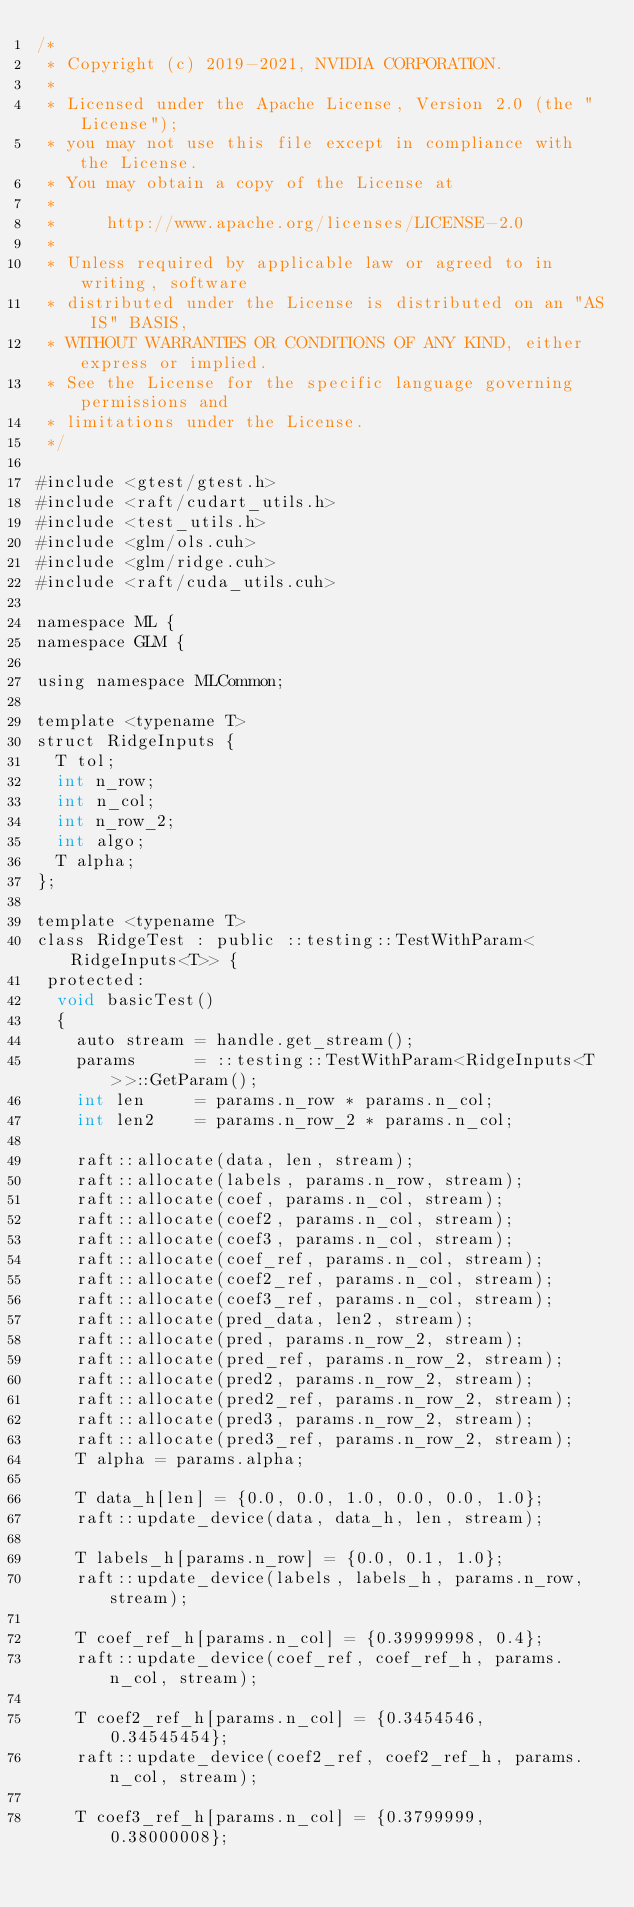Convert code to text. <code><loc_0><loc_0><loc_500><loc_500><_Cuda_>/*
 * Copyright (c) 2019-2021, NVIDIA CORPORATION.
 *
 * Licensed under the Apache License, Version 2.0 (the "License");
 * you may not use this file except in compliance with the License.
 * You may obtain a copy of the License at
 *
 *     http://www.apache.org/licenses/LICENSE-2.0
 *
 * Unless required by applicable law or agreed to in writing, software
 * distributed under the License is distributed on an "AS IS" BASIS,
 * WITHOUT WARRANTIES OR CONDITIONS OF ANY KIND, either express or implied.
 * See the License for the specific language governing permissions and
 * limitations under the License.
 */

#include <gtest/gtest.h>
#include <raft/cudart_utils.h>
#include <test_utils.h>
#include <glm/ols.cuh>
#include <glm/ridge.cuh>
#include <raft/cuda_utils.cuh>

namespace ML {
namespace GLM {

using namespace MLCommon;

template <typename T>
struct RidgeInputs {
  T tol;
  int n_row;
  int n_col;
  int n_row_2;
  int algo;
  T alpha;
};

template <typename T>
class RidgeTest : public ::testing::TestWithParam<RidgeInputs<T>> {
 protected:
  void basicTest()
  {
    auto stream = handle.get_stream();
    params      = ::testing::TestWithParam<RidgeInputs<T>>::GetParam();
    int len     = params.n_row * params.n_col;
    int len2    = params.n_row_2 * params.n_col;

    raft::allocate(data, len, stream);
    raft::allocate(labels, params.n_row, stream);
    raft::allocate(coef, params.n_col, stream);
    raft::allocate(coef2, params.n_col, stream);
    raft::allocate(coef3, params.n_col, stream);
    raft::allocate(coef_ref, params.n_col, stream);
    raft::allocate(coef2_ref, params.n_col, stream);
    raft::allocate(coef3_ref, params.n_col, stream);
    raft::allocate(pred_data, len2, stream);
    raft::allocate(pred, params.n_row_2, stream);
    raft::allocate(pred_ref, params.n_row_2, stream);
    raft::allocate(pred2, params.n_row_2, stream);
    raft::allocate(pred2_ref, params.n_row_2, stream);
    raft::allocate(pred3, params.n_row_2, stream);
    raft::allocate(pred3_ref, params.n_row_2, stream);
    T alpha = params.alpha;

    T data_h[len] = {0.0, 0.0, 1.0, 0.0, 0.0, 1.0};
    raft::update_device(data, data_h, len, stream);

    T labels_h[params.n_row] = {0.0, 0.1, 1.0};
    raft::update_device(labels, labels_h, params.n_row, stream);

    T coef_ref_h[params.n_col] = {0.39999998, 0.4};
    raft::update_device(coef_ref, coef_ref_h, params.n_col, stream);

    T coef2_ref_h[params.n_col] = {0.3454546, 0.34545454};
    raft::update_device(coef2_ref, coef2_ref_h, params.n_col, stream);

    T coef3_ref_h[params.n_col] = {0.3799999, 0.38000008};</code> 